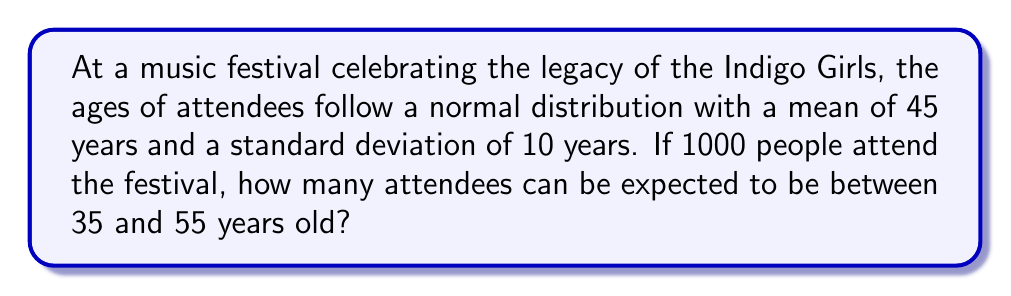Can you solve this math problem? Let's approach this step-by-step:

1) First, we need to calculate the z-scores for the given age range:

   For 35 years: $z_1 = \frac{35 - 45}{10} = -1$
   For 55 years: $z_2 = \frac{55 - 45}{10} = 1$

2) Now, we need to find the area under the standard normal curve between these z-scores. This represents the probability of an attendee being between 35 and 55 years old.

3) Using a standard normal table or calculator:
   $P(-1 < Z < 1) = P(Z < 1) - P(Z < -1)$
                  $= 0.8413 - 0.1587$
                  $= 0.6826$

4) This means that approximately 68.26% of the attendees are expected to be between 35 and 55 years old.

5) Given that there are 1000 attendees in total, we can calculate the expected number of attendees in this age range:

   $1000 * 0.6826 = 682.6$

6) Since we're dealing with people, we round to the nearest whole number.
Answer: 683 attendees 